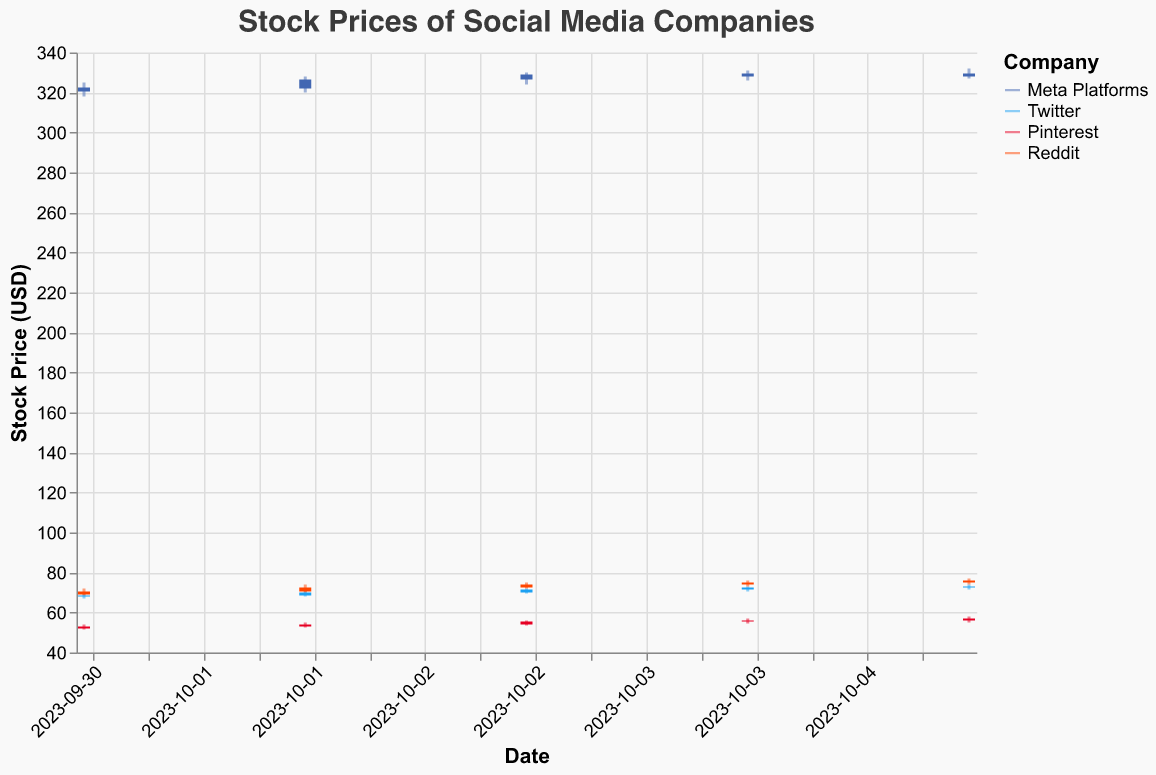What is the title of the figure? The title is typically found at the top of the figure.
Answer: Stock Prices of Social Media Companies Which company had the highest closing stock price on October 3rd, 2023? Look for the data corresponding to October 3rd for each company, then identify the highest closing price from those entries. Meta Platforms closed at 329.00, Twitter closed at 71.50, Pinterest closed at 55.50, and Reddit closed at 74.00.
Answer: Meta Platforms How did the stock price of Twitter change from October 1st to October 5th? Examine the opening and closing prices of Twitter from October 1st to October 5th. On October 1st, the closing price was 68.50 and on October 5th, it was 73.00.
Answer: Increased Which company had the lowest trading volume on October 2nd, 2023? Look for the trading volume data corresponding to October 2nd for each company. Meta Platforms: 16230000, Twitter: 6032000, Pinterest: 4456000, Reddit: 6273000. The lowest volume is 4456000 for Pinterest.
Answer: Pinterest What was the highest stock price recorded by Reddit during this period? Check the "High" values for Reddit entries from October 1st to October 5th. The values are: 72.00, 74.00, 75.00, 76.00, 77.00. The highest is 77.00.
Answer: 77.00 Compare the closing stock prices of Pinterest and Reddit on October 4th, 2023. Which one was higher? Locate the closing prices for Pinterest and Reddit on October 4th. Pinterest closed at 56.00 and Reddit at 75.00.
Answer: Reddit What was the average closing price of Meta Platforms over the five-day period? Sum the closing prices of Meta Platforms from October 1st to October 5th and then divide by 5. The closing prices are: 322.50, 326.50, 329.00, 329.50, and 328.00. The sum is 1635.50, so the average is 1635.50/5 = 327.10
Answer: 327.10 Which company showed the greatest variance in its stock price during this period? Calculate the range (High - Low) for each company across all days and determine which company has the highest. Meta Platforms: 332.00 - 318.00 = 14.00, Twitter: 74.00 - 67.00 = 7.00, Pinterest: 58.00 - 51.50 = 6.50, Reddit: 77.00 - 68.50 = 8.50. Meta Platforms has the greatest variance.
Answer: Meta Platforms 